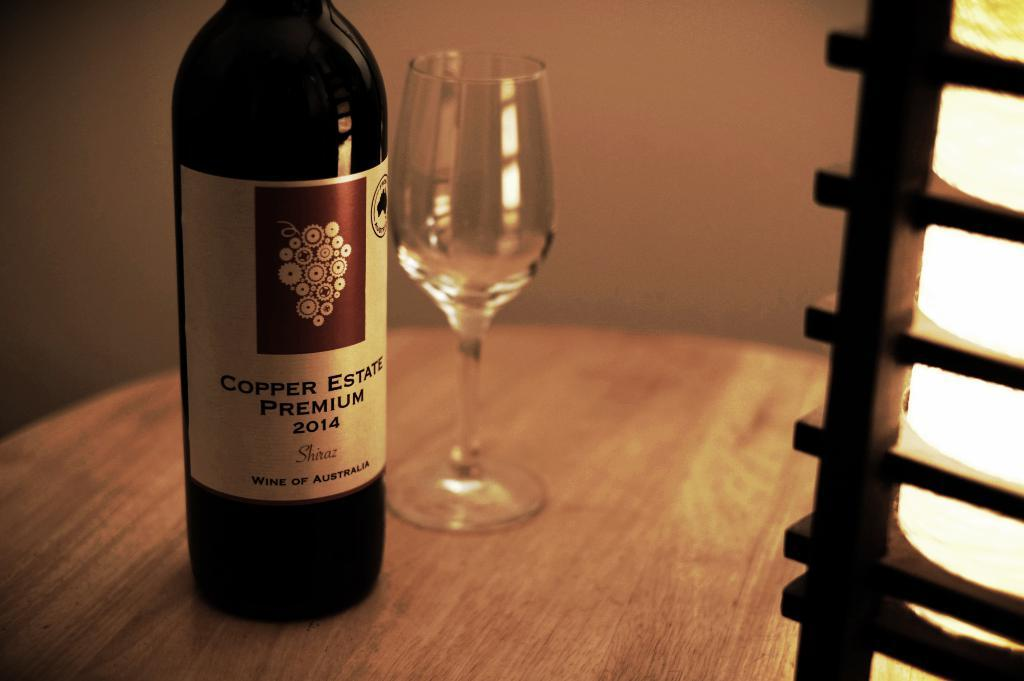What is on the table in the image? There is a bottle and a glass on the table in the image. What type of material is the wall made of? The wall in the image is made of wood. Can you describe the lighting in the image? There is some lighting in the image, but the specific type or source is not mentioned. What type of orange is being used to write with ink in the image? There is no orange or ink present in the image; it only features a bottle, a glass, and a wooden wall. 